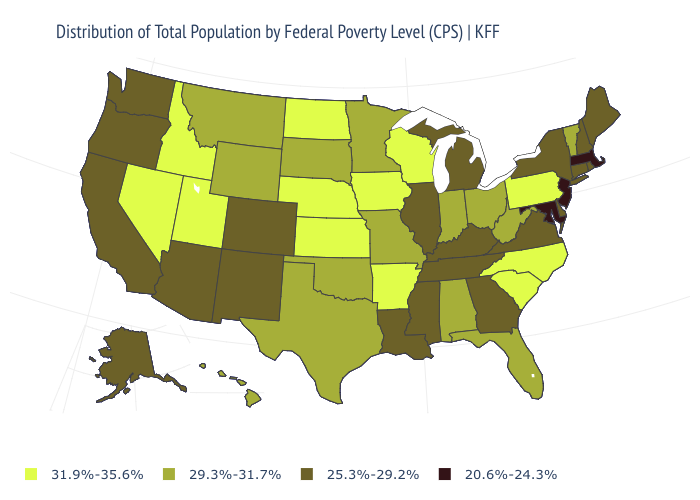Name the states that have a value in the range 25.3%-29.2%?
Short answer required. Alaska, Arizona, California, Colorado, Connecticut, Delaware, Georgia, Illinois, Kentucky, Louisiana, Maine, Michigan, Mississippi, New Hampshire, New Mexico, New York, Oregon, Rhode Island, Tennessee, Virginia, Washington. Name the states that have a value in the range 29.3%-31.7%?
Quick response, please. Alabama, Florida, Hawaii, Indiana, Minnesota, Missouri, Montana, Ohio, Oklahoma, South Dakota, Texas, Vermont, West Virginia, Wyoming. Does Connecticut have a higher value than New Jersey?
Concise answer only. Yes. Name the states that have a value in the range 31.9%-35.6%?
Quick response, please. Arkansas, Idaho, Iowa, Kansas, Nebraska, Nevada, North Carolina, North Dakota, Pennsylvania, South Carolina, Utah, Wisconsin. Name the states that have a value in the range 25.3%-29.2%?
Quick response, please. Alaska, Arizona, California, Colorado, Connecticut, Delaware, Georgia, Illinois, Kentucky, Louisiana, Maine, Michigan, Mississippi, New Hampshire, New Mexico, New York, Oregon, Rhode Island, Tennessee, Virginia, Washington. Name the states that have a value in the range 29.3%-31.7%?
Be succinct. Alabama, Florida, Hawaii, Indiana, Minnesota, Missouri, Montana, Ohio, Oklahoma, South Dakota, Texas, Vermont, West Virginia, Wyoming. Name the states that have a value in the range 25.3%-29.2%?
Quick response, please. Alaska, Arizona, California, Colorado, Connecticut, Delaware, Georgia, Illinois, Kentucky, Louisiana, Maine, Michigan, Mississippi, New Hampshire, New Mexico, New York, Oregon, Rhode Island, Tennessee, Virginia, Washington. What is the value of Florida?
Keep it brief. 29.3%-31.7%. Does Illinois have the same value as Michigan?
Be succinct. Yes. Does West Virginia have the same value as Wisconsin?
Quick response, please. No. Name the states that have a value in the range 31.9%-35.6%?
Be succinct. Arkansas, Idaho, Iowa, Kansas, Nebraska, Nevada, North Carolina, North Dakota, Pennsylvania, South Carolina, Utah, Wisconsin. What is the value of Pennsylvania?
Write a very short answer. 31.9%-35.6%. What is the value of Colorado?
Keep it brief. 25.3%-29.2%. What is the value of Missouri?
Quick response, please. 29.3%-31.7%. Which states have the lowest value in the Northeast?
Answer briefly. Massachusetts, New Jersey. 